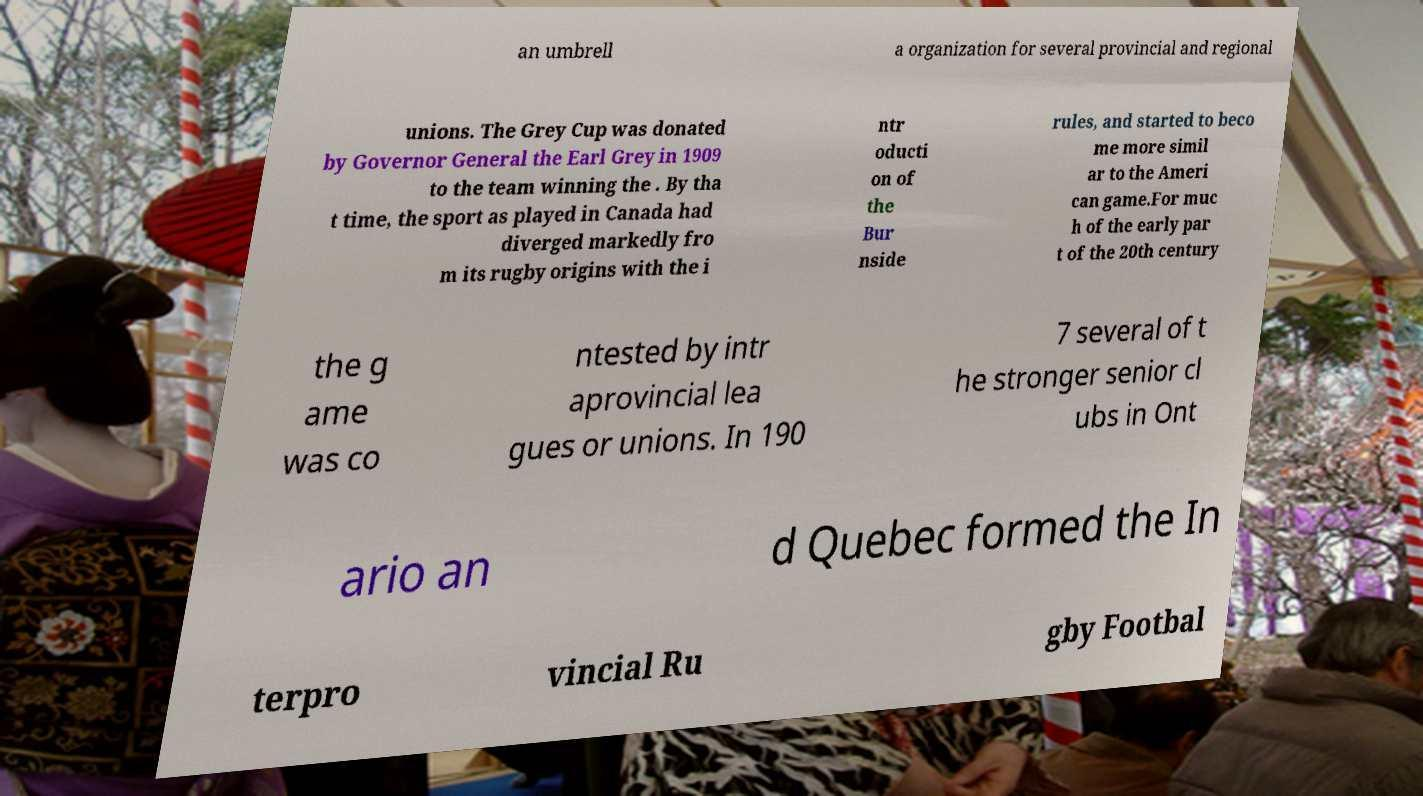I need the written content from this picture converted into text. Can you do that? an umbrell a organization for several provincial and regional unions. The Grey Cup was donated by Governor General the Earl Grey in 1909 to the team winning the . By tha t time, the sport as played in Canada had diverged markedly fro m its rugby origins with the i ntr oducti on of the Bur nside rules, and started to beco me more simil ar to the Ameri can game.For muc h of the early par t of the 20th century the g ame was co ntested by intr aprovincial lea gues or unions. In 190 7 several of t he stronger senior cl ubs in Ont ario an d Quebec formed the In terpro vincial Ru gby Footbal 